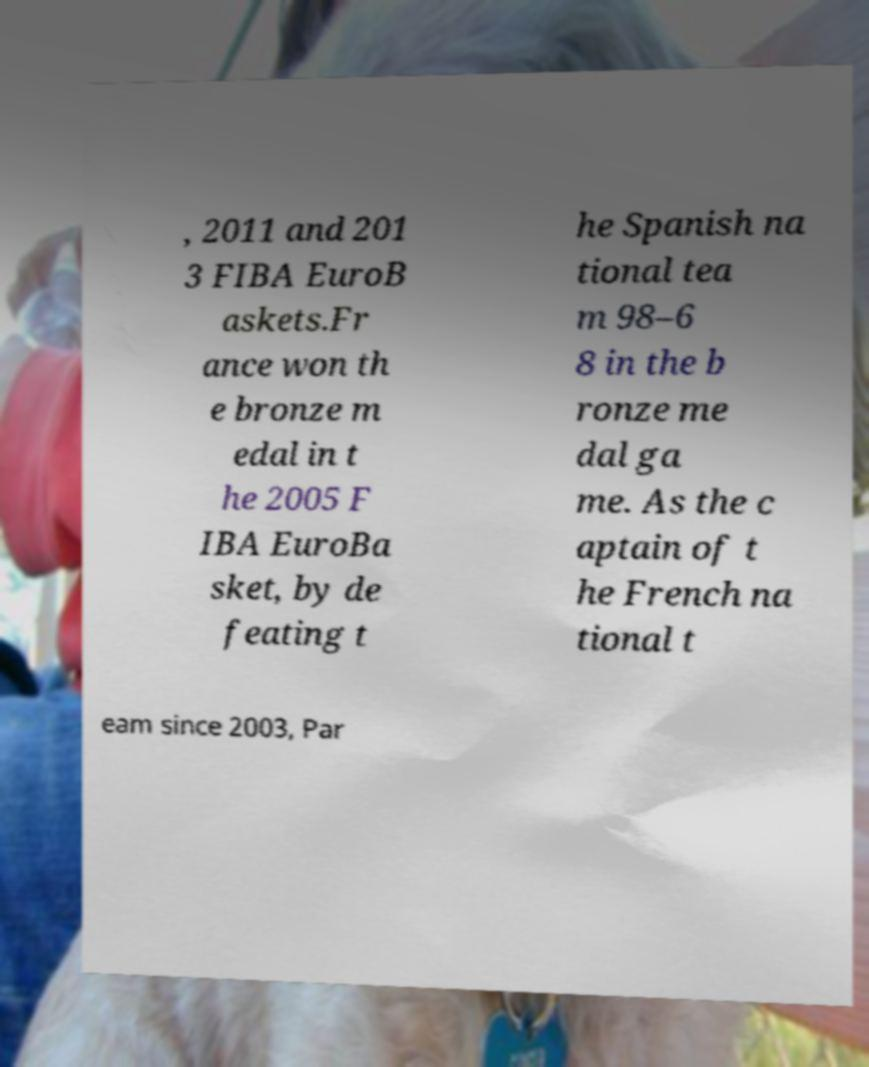For documentation purposes, I need the text within this image transcribed. Could you provide that? , 2011 and 201 3 FIBA EuroB askets.Fr ance won th e bronze m edal in t he 2005 F IBA EuroBa sket, by de feating t he Spanish na tional tea m 98–6 8 in the b ronze me dal ga me. As the c aptain of t he French na tional t eam since 2003, Par 